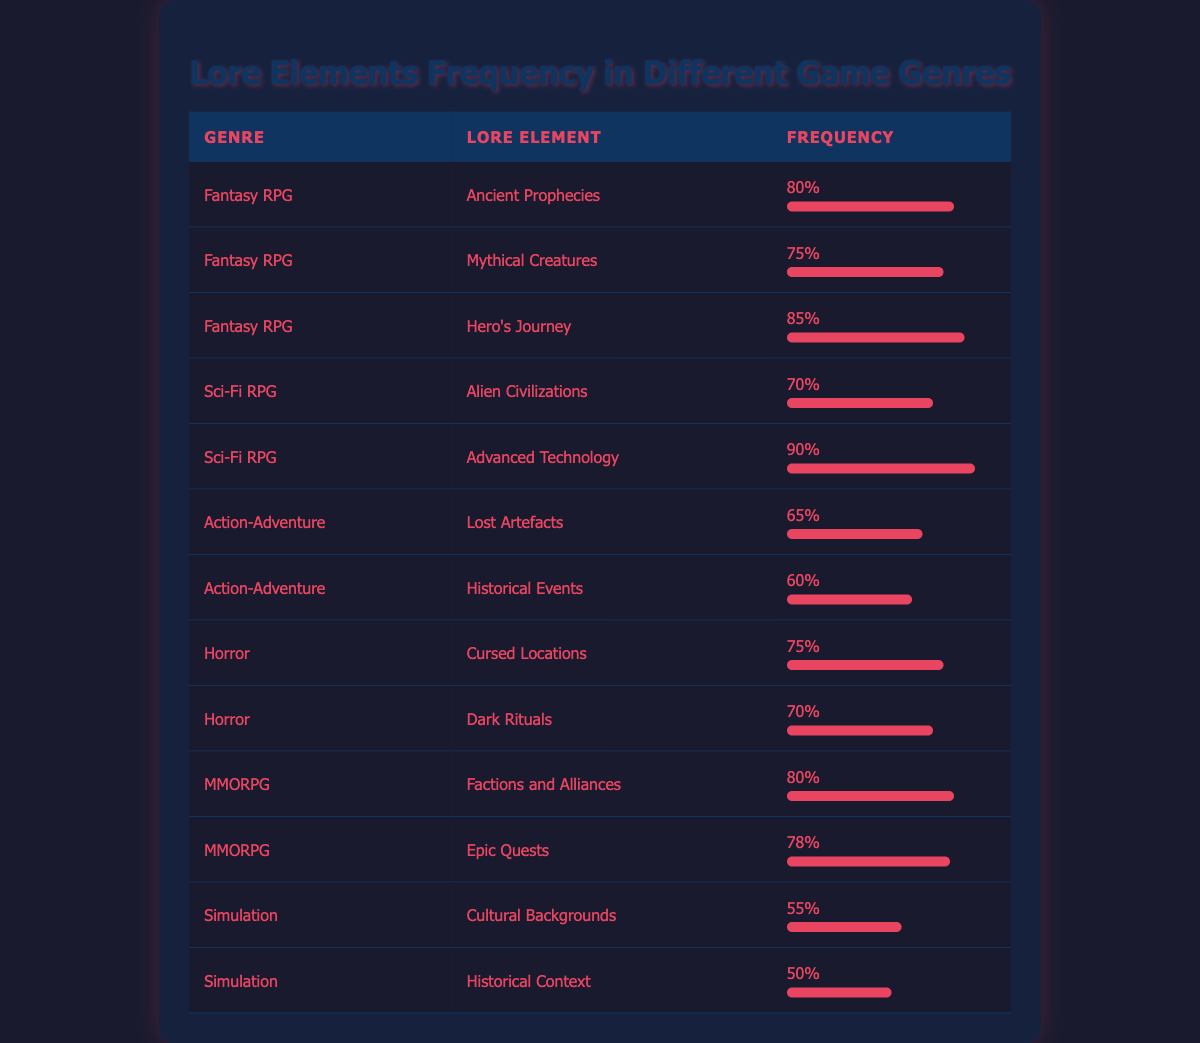What is the frequency of "Hero's Journey" in Fantasy RPG? The data lists "Hero's Journey" under the "Fantasy RPG" genre with a frequency of 85. This can be found in the corresponding row for that genre.
Answer: 85 Which lore element appears most frequently in the Sci-Fi RPG genre? In the Sci-Fi RPG genre, there are two lore elements: "Alien Civilizations" with a frequency of 70 and "Advanced Technology" with a frequency of 90. "Advanced Technology" has the higher frequency, making it the most frequent.
Answer: Advanced Technology Is there any horror lore element with a frequency greater than 75? The horror lore elements listed are "Cursed Locations" with a frequency of 75 and "Dark Rituals" with a frequency of 70. Since both frequencies do not exceed 75, the answer is no.
Answer: No What is the average frequency of lore elements in the Simulation genre? The Simulation genre has two lore elements: "Cultural Backgrounds" with a frequency of 55 and "Historical Context" with a frequency of 50. The average is calculated as (55 + 50) / 2 = 52.5.
Answer: 52.5 What genre contains the most lore elements with a frequency above 75? The Fantasy RPG genre has three lore elements: "Ancient Prophecies" (80), "Mythical Creatures" (75), and "Hero's Journey" (85). The MMORPG genre has two: "Factions and Alliances" (80) and "Epic Quests" (78). Since Fantasy RPG contains three lore elements, it has the most.
Answer: Fantasy RPG What is the total frequency of lore elements in the Action-Adventure genre? The Action-Adventure genre consists of "Lost Artefacts" with a frequency of 65 and "Historical Events" with a frequency of 60. To find the total frequency, sum them up: 65 + 60 = 125.
Answer: 125 Does the Fantasy RPG genre have any lore elements with a frequency of 60 or lower? The Fantasy RPG genre consists of three lore elements, all with frequencies higher than 60: "Ancient Prophecies" (80), "Mythical Creatures" (75), and "Hero's Journey" (85). Therefore, the answer is no.
Answer: No What is the difference in frequency between "Cultural Backgrounds" and "Cursed Locations"? "Cultural Backgrounds" has a frequency of 55 and "Cursed Locations" has a frequency of 75. To find the difference, subtract: 75 - 55 = 20.
Answer: 20 Which genre has a frequency of 60 for any lore element? The Action-Adventure genre has "Historical Events" with a frequency of 60. No other genres are listed with this specific frequency for any lore element.
Answer: Action-Adventure 